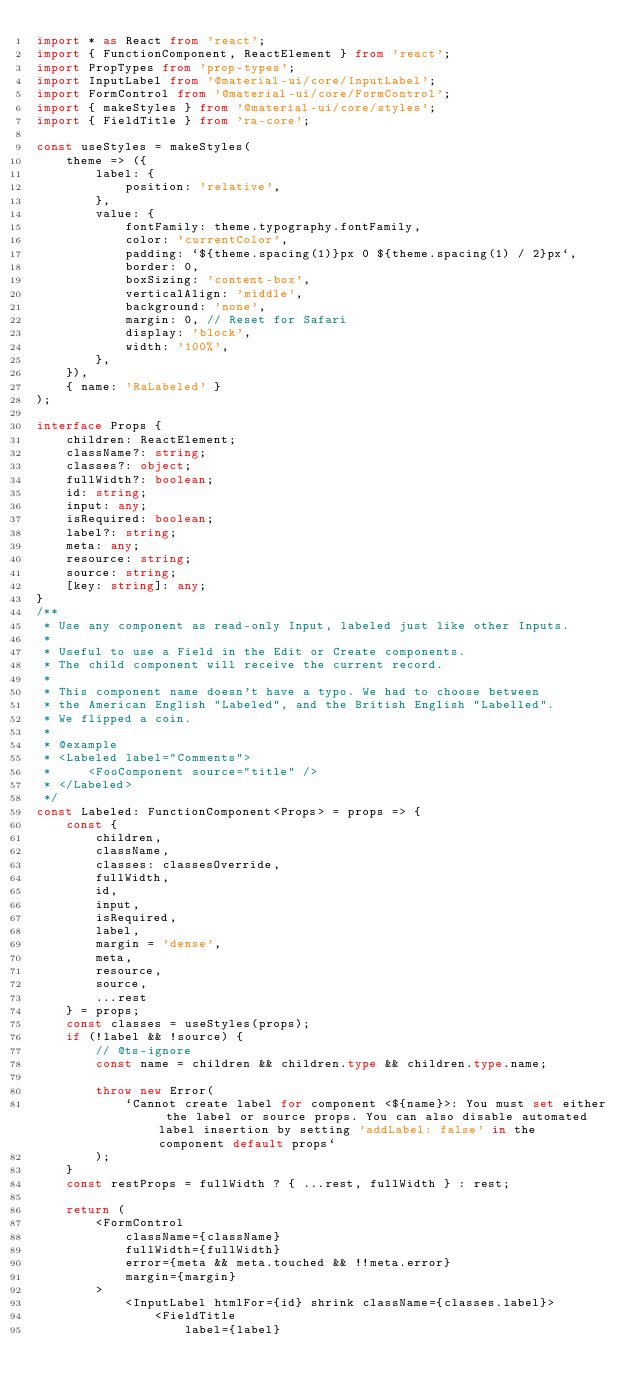<code> <loc_0><loc_0><loc_500><loc_500><_TypeScript_>import * as React from 'react';
import { FunctionComponent, ReactElement } from 'react';
import PropTypes from 'prop-types';
import InputLabel from '@material-ui/core/InputLabel';
import FormControl from '@material-ui/core/FormControl';
import { makeStyles } from '@material-ui/core/styles';
import { FieldTitle } from 'ra-core';

const useStyles = makeStyles(
    theme => ({
        label: {
            position: 'relative',
        },
        value: {
            fontFamily: theme.typography.fontFamily,
            color: 'currentColor',
            padding: `${theme.spacing(1)}px 0 ${theme.spacing(1) / 2}px`,
            border: 0,
            boxSizing: 'content-box',
            verticalAlign: 'middle',
            background: 'none',
            margin: 0, // Reset for Safari
            display: 'block',
            width: '100%',
        },
    }),
    { name: 'RaLabeled' }
);

interface Props {
    children: ReactElement;
    className?: string;
    classes?: object;
    fullWidth?: boolean;
    id: string;
    input: any;
    isRequired: boolean;
    label?: string;
    meta: any;
    resource: string;
    source: string;
    [key: string]: any;
}
/**
 * Use any component as read-only Input, labeled just like other Inputs.
 *
 * Useful to use a Field in the Edit or Create components.
 * The child component will receive the current record.
 *
 * This component name doesn't have a typo. We had to choose between
 * the American English "Labeled", and the British English "Labelled".
 * We flipped a coin.
 *
 * @example
 * <Labeled label="Comments">
 *     <FooComponent source="title" />
 * </Labeled>
 */
const Labeled: FunctionComponent<Props> = props => {
    const {
        children,
        className,
        classes: classesOverride,
        fullWidth,
        id,
        input,
        isRequired,
        label,
        margin = 'dense',
        meta,
        resource,
        source,
        ...rest
    } = props;
    const classes = useStyles(props);
    if (!label && !source) {
        // @ts-ignore
        const name = children && children.type && children.type.name;

        throw new Error(
            `Cannot create label for component <${name}>: You must set either the label or source props. You can also disable automated label insertion by setting 'addLabel: false' in the component default props`
        );
    }
    const restProps = fullWidth ? { ...rest, fullWidth } : rest;

    return (
        <FormControl
            className={className}
            fullWidth={fullWidth}
            error={meta && meta.touched && !!meta.error}
            margin={margin}
        >
            <InputLabel htmlFor={id} shrink className={classes.label}>
                <FieldTitle
                    label={label}</code> 